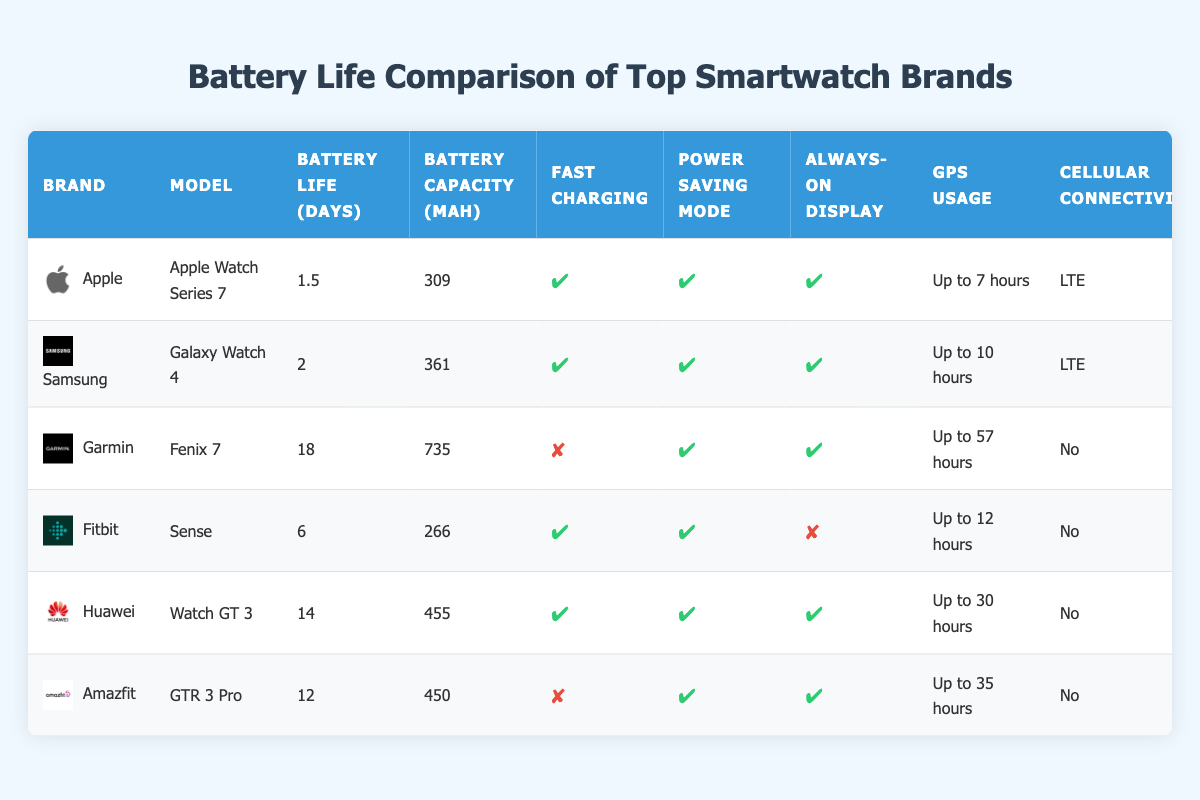What is the battery life of the Apple Watch Series 7? The table lists the battery life for each model, and for the Apple Watch Series 7, it states "1.5" days as the battery life.
Answer: 1.5 Which smartwatch has the longest battery life? By inspecting the battery life values, the Garmin Fenix 7 has the highest value with "18" days.
Answer: 18 days Do any smartwatches support fast charging? The table includes a column for fast charging and lists multiple brands. The Apple Watch Series 7, Samsung Galaxy Watch 4, Fitbit Sense, Huawei Watch GT 3, and Garmin Fenix 7 all have this feature marked as true.
Answer: Yes How many smartwatches have an always-on display feature? Counting from the always-on display column, five out of six smartwatches (all except Fitbit Sense) have this feature indicated as true.
Answer: 5 What is the average battery capacity of the listed smartwatches? To find the average, sum the battery capacities: 309 + 361 + 735 + 266 + 455 + 450 = 2576 mAh. There are six devices, so divide by 6: 2576 / 6 = 429.33 mAh.
Answer: 429.33 mAh What is the difference in battery life between the Huawei Watch GT 3 and the Garmin Fenix 7? The Huawei Watch GT 3 has a battery life of "14" days, while the Garmin Fenix 7 has "18" days. The difference is 18 - 14 = 4 days.
Answer: 4 days Is the GPS usage for the Fitbit Sense longer than that of the Apple Watch Series 7? The GPS usage for Fitbit Sense is "Up to 12 hours," while for the Apple Watch Series 7 it is "Up to 7 hours." Therefore, it can be concluded that Fitbit Sense has a longer GPS usage.
Answer: Yes 